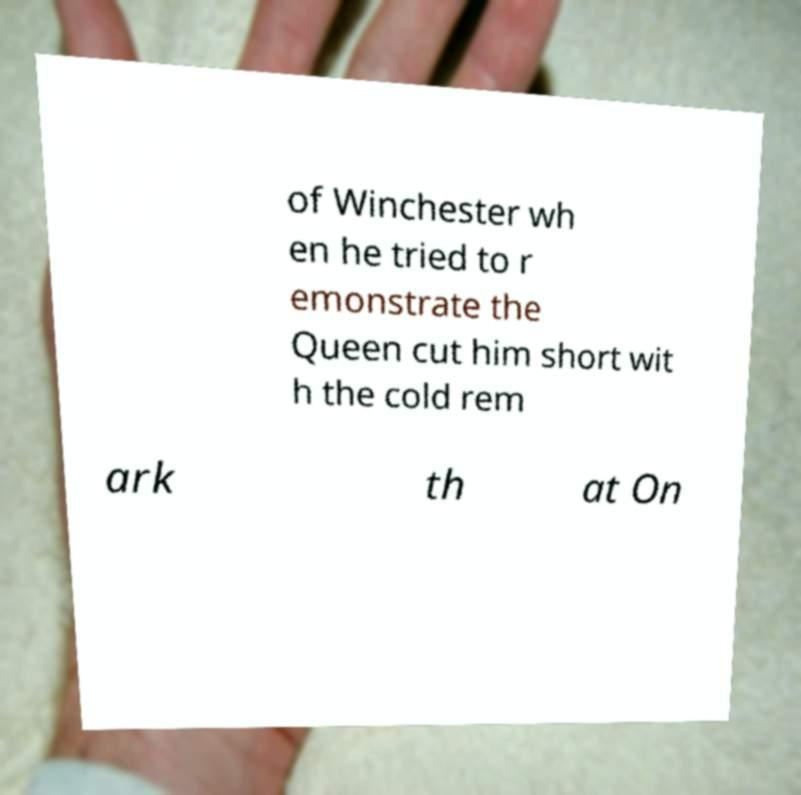I need the written content from this picture converted into text. Can you do that? of Winchester wh en he tried to r emonstrate the Queen cut him short wit h the cold rem ark th at On 